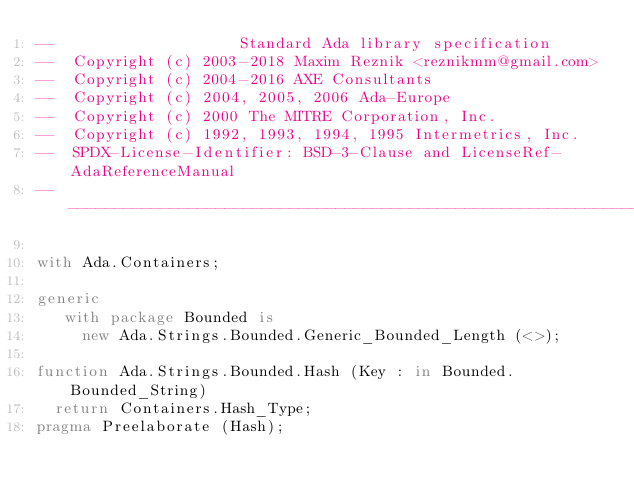<code> <loc_0><loc_0><loc_500><loc_500><_Ada_>--                    Standard Ada library specification
--  Copyright (c) 2003-2018 Maxim Reznik <reznikmm@gmail.com>
--  Copyright (c) 2004-2016 AXE Consultants
--  Copyright (c) 2004, 2005, 2006 Ada-Europe
--  Copyright (c) 2000 The MITRE Corporation, Inc.
--  Copyright (c) 1992, 1993, 1994, 1995 Intermetrics, Inc.
--  SPDX-License-Identifier: BSD-3-Clause and LicenseRef-AdaReferenceManual
---------------------------------------------------------------------------

with Ada.Containers;

generic
   with package Bounded is
     new Ada.Strings.Bounded.Generic_Bounded_Length (<>);

function Ada.Strings.Bounded.Hash (Key : in Bounded.Bounded_String)
  return Containers.Hash_Type;
pragma Preelaborate (Hash);
</code> 